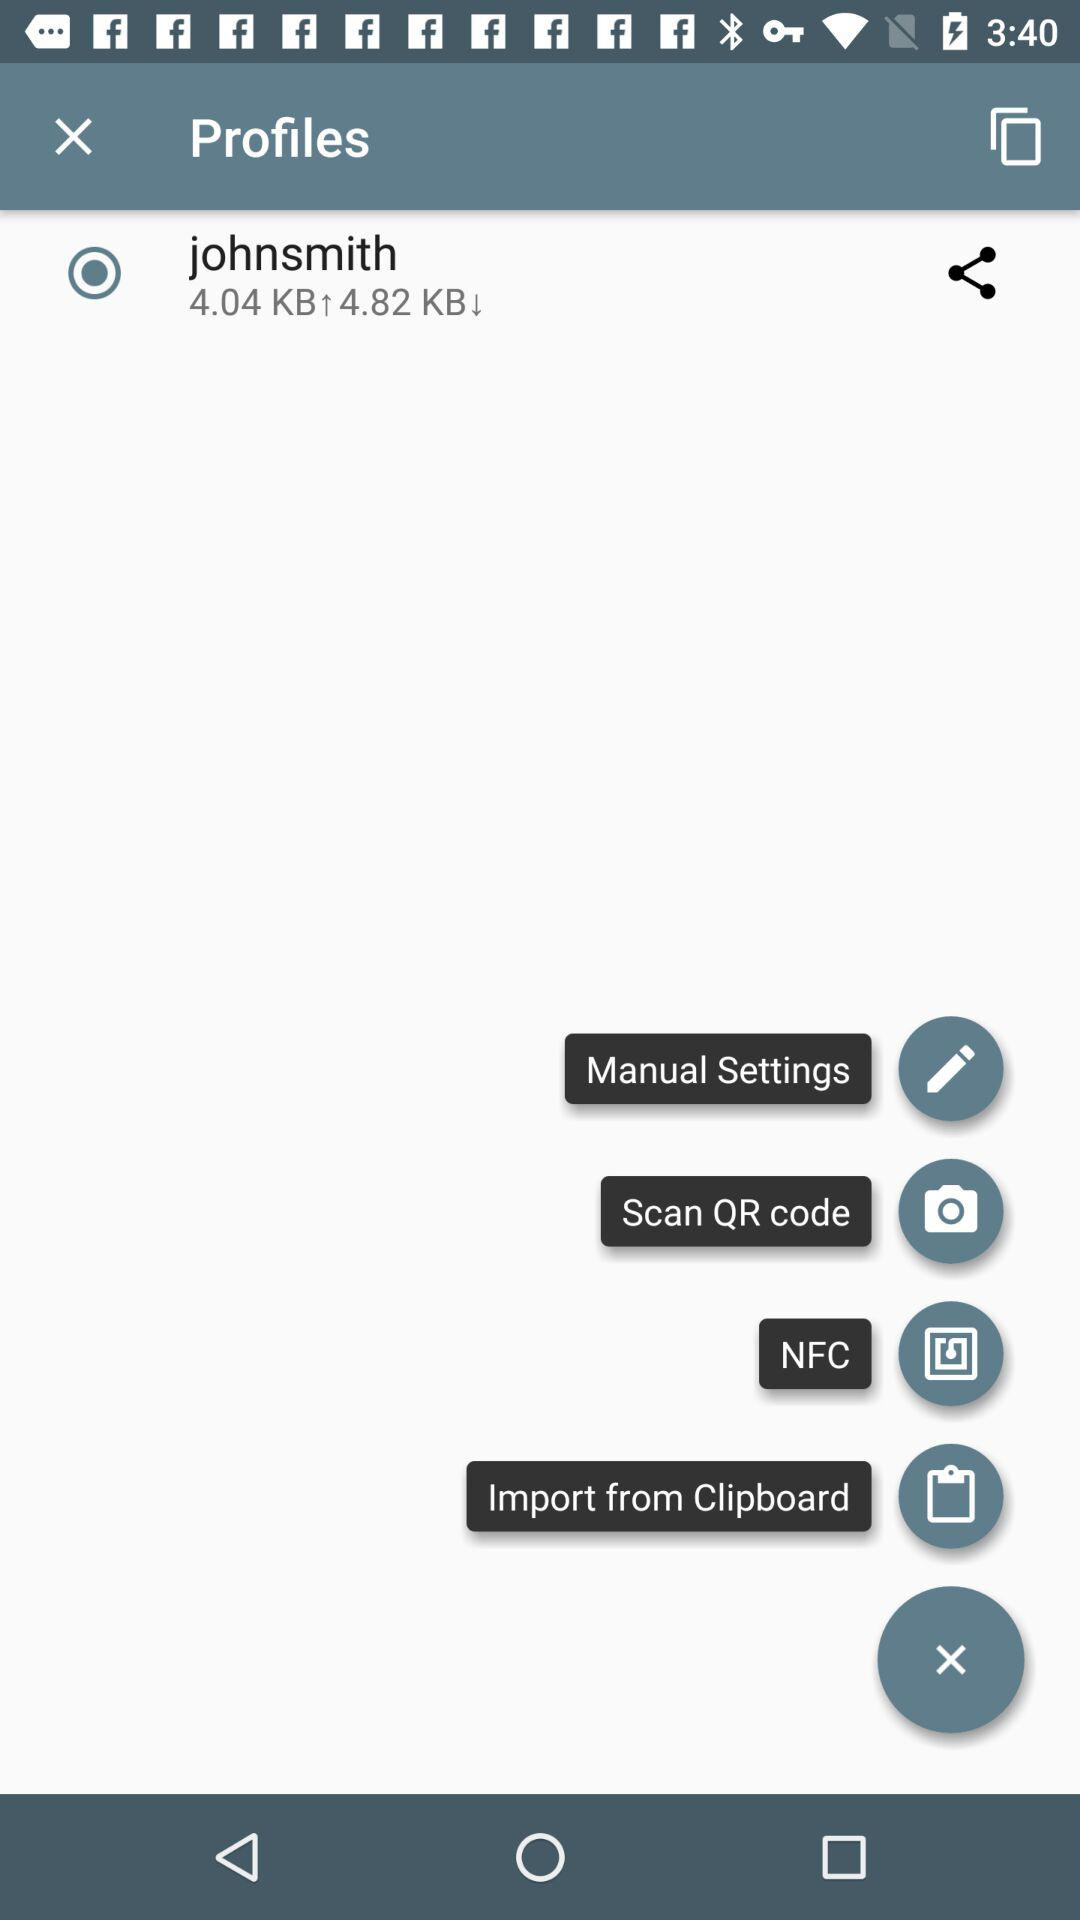What is the name of the user? The user name is John Smith. 